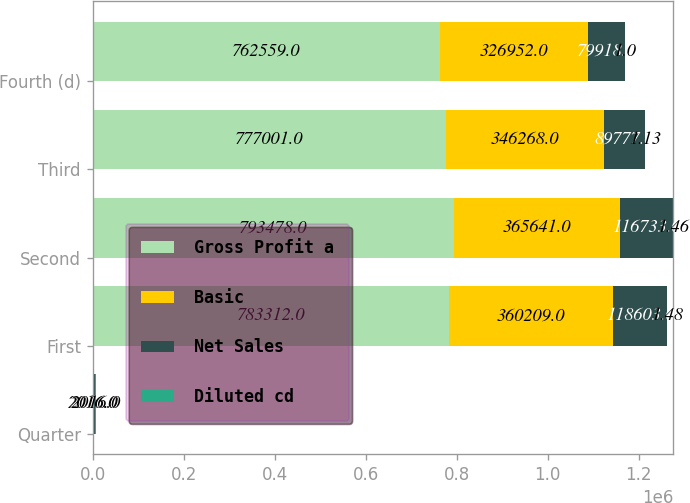Convert chart. <chart><loc_0><loc_0><loc_500><loc_500><stacked_bar_chart><ecel><fcel>Quarter<fcel>First<fcel>Second<fcel>Third<fcel>Fourth (d)<nl><fcel>Gross Profit a<fcel>2016<fcel>783312<fcel>793478<fcel>777001<fcel>762559<nl><fcel>Basic<fcel>2016<fcel>360209<fcel>365641<fcel>346268<fcel>326952<nl><fcel>Net Sales<fcel>2016<fcel>118603<fcel>116733<fcel>89777<fcel>79918<nl><fcel>Diluted cd<fcel>2016<fcel>1.48<fcel>1.46<fcel>1.13<fcel>1<nl></chart> 